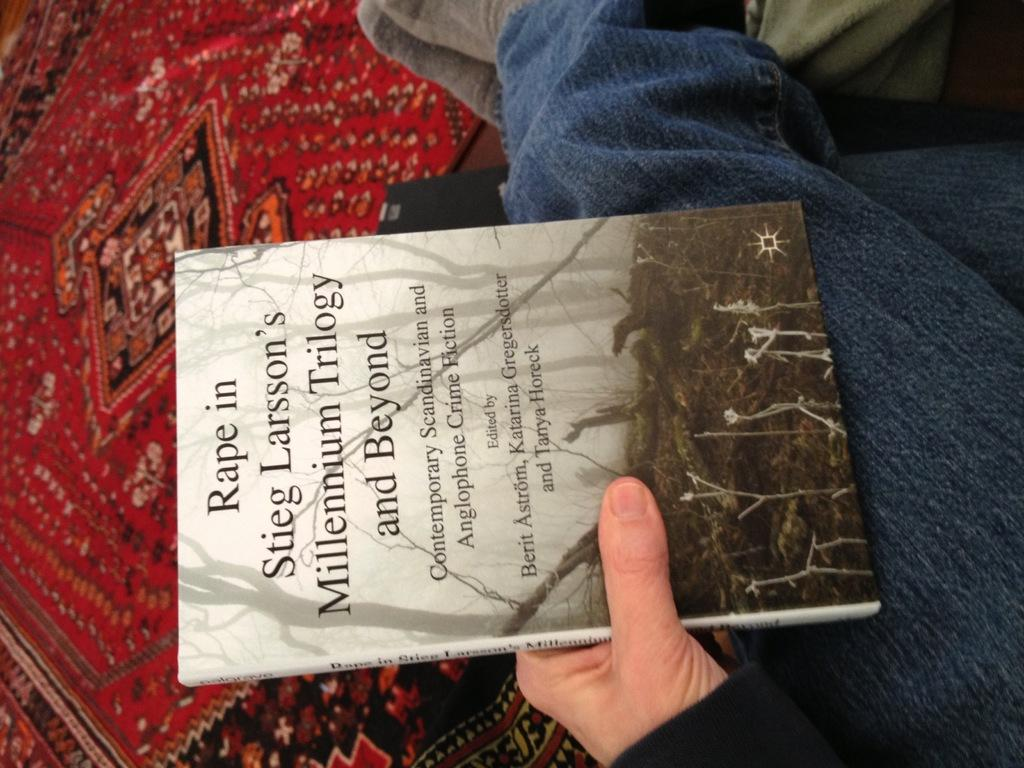What is the person in the image doing? The person is holding a book in their hand. Where is the person sitting in the image? The person is sitting on a bed. What else can be seen in the image besides the person and the book? There are clothes visible in the image. What type of location is suggested by the presence of a bed and clothes? The image is likely taken in a room. What type of chess pieces can be seen on the bed in the image? There are no chess pieces visible in the image; the person is holding a book and sitting on a bed with clothes nearby. 